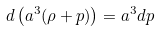<formula> <loc_0><loc_0><loc_500><loc_500>d \left ( a ^ { 3 } ( \rho + p ) \right ) = a ^ { 3 } d p</formula> 